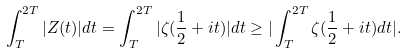<formula> <loc_0><loc_0><loc_500><loc_500>\int _ { T } ^ { 2 T } | Z ( t ) | d t = \int _ { T } ^ { 2 T } | \zeta ( \frac { 1 } { 2 } + i t ) | d t \geq | \int _ { T } ^ { 2 T } \zeta ( \frac { 1 } { 2 } + i t ) d t | .</formula> 